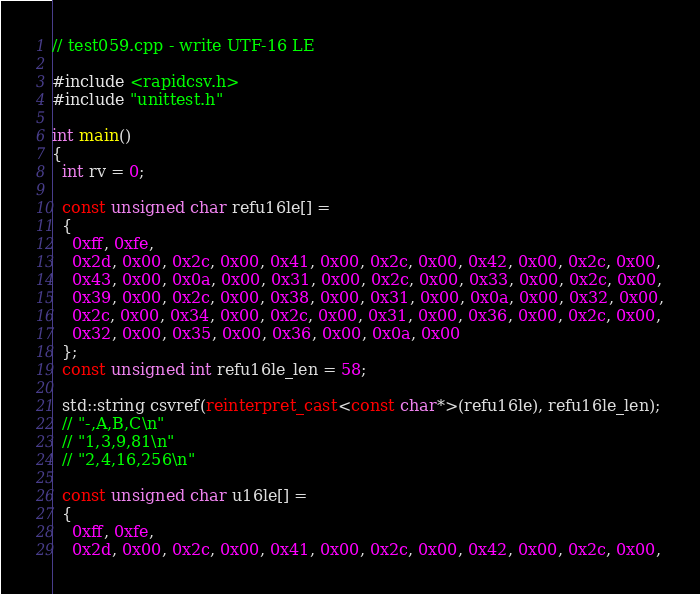Convert code to text. <code><loc_0><loc_0><loc_500><loc_500><_C++_>// test059.cpp - write UTF-16 LE

#include <rapidcsv.h>
#include "unittest.h"

int main()
{
  int rv = 0;

  const unsigned char refu16le[] =
  {
    0xff, 0xfe,
    0x2d, 0x00, 0x2c, 0x00, 0x41, 0x00, 0x2c, 0x00, 0x42, 0x00, 0x2c, 0x00,
    0x43, 0x00, 0x0a, 0x00, 0x31, 0x00, 0x2c, 0x00, 0x33, 0x00, 0x2c, 0x00,
    0x39, 0x00, 0x2c, 0x00, 0x38, 0x00, 0x31, 0x00, 0x0a, 0x00, 0x32, 0x00,
    0x2c, 0x00, 0x34, 0x00, 0x2c, 0x00, 0x31, 0x00, 0x36, 0x00, 0x2c, 0x00,
    0x32, 0x00, 0x35, 0x00, 0x36, 0x00, 0x0a, 0x00
  };
  const unsigned int refu16le_len = 58;
  
  std::string csvref(reinterpret_cast<const char*>(refu16le), refu16le_len);
  // "-,A,B,C\n"
  // "1,3,9,81\n"
  // "2,4,16,256\n"

  const unsigned char u16le[] =
  {
    0xff, 0xfe,
    0x2d, 0x00, 0x2c, 0x00, 0x41, 0x00, 0x2c, 0x00, 0x42, 0x00, 0x2c, 0x00,</code> 